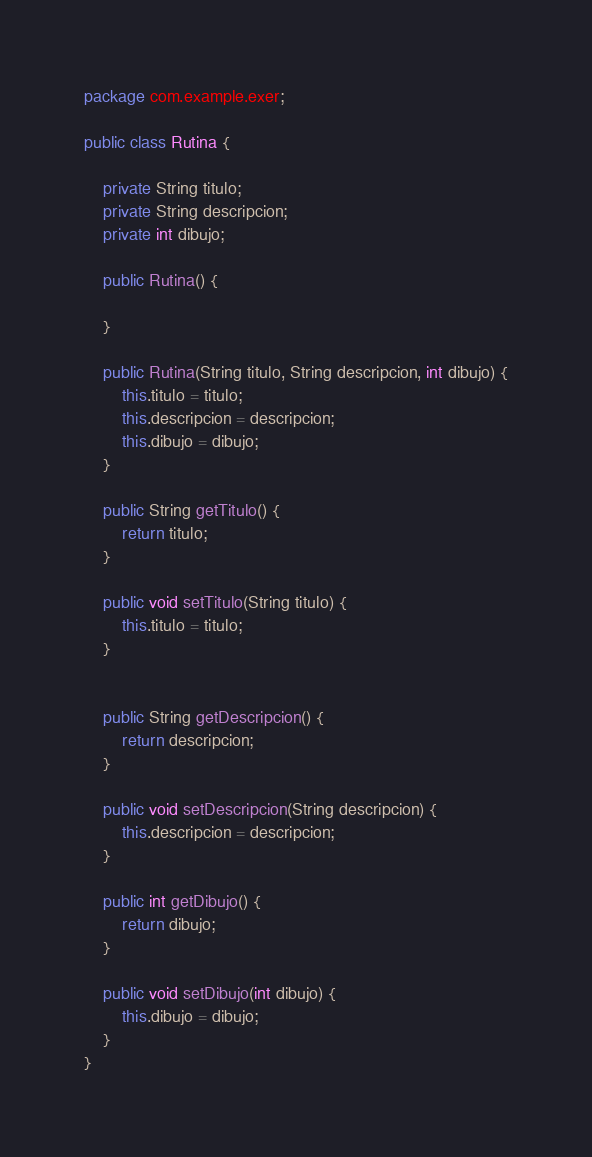<code> <loc_0><loc_0><loc_500><loc_500><_Java_>package com.example.exer;

public class Rutina {

    private String titulo;
    private String descripcion;
    private int dibujo;

    public Rutina() {

    }

    public Rutina(String titulo, String descripcion, int dibujo) {
        this.titulo = titulo;
        this.descripcion = descripcion;
        this.dibujo = dibujo;
    }

    public String getTitulo() {
        return titulo;
    }

    public void setTitulo(String titulo) {
        this.titulo = titulo;
    }


    public String getDescripcion() {
        return descripcion;
    }

    public void setDescripcion(String descripcion) {
        this.descripcion = descripcion;
    }

    public int getDibujo() {
        return dibujo;
    }

    public void setDibujo(int dibujo) {
        this.dibujo = dibujo;
    }
}
</code> 